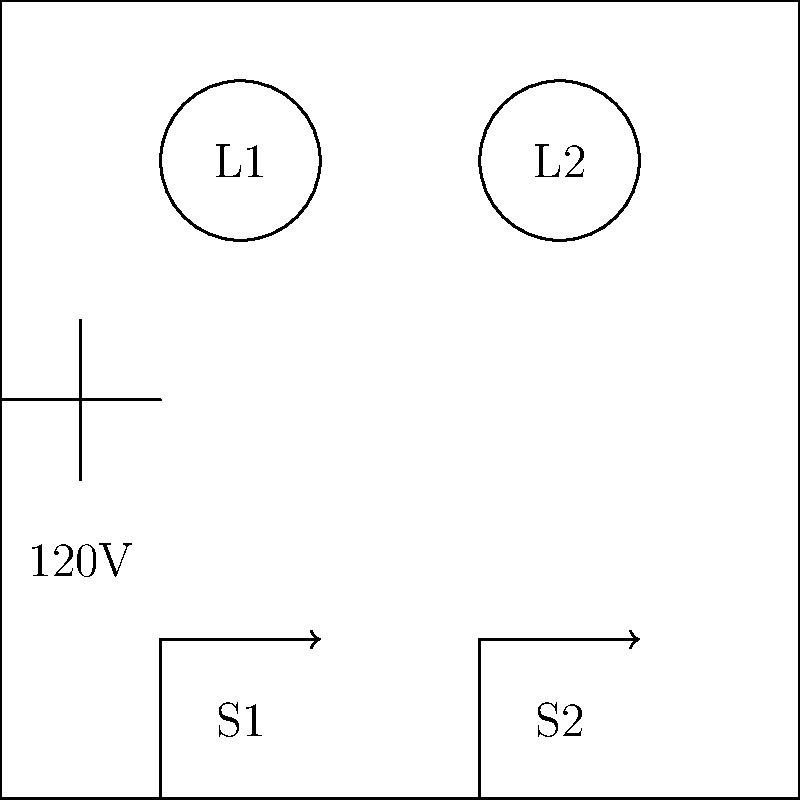In the residential electrical wiring schematic shown above, which represents a simple lighting circuit in a typical Oxfordshire home, what will happen when switch S1 is closed and switch S2 is open? To answer this question, let's analyze the circuit step-by-step:

1. The circuit shows a 120V power source, which is typical for residential lighting circuits.

2. There are two switches (S1 and S2) and two light bulbs (L1 and L2) in the circuit.

3. The switches and light bulbs are connected in parallel to the power source.

4. When a switch is closed, it completes the circuit for its corresponding light bulb.

5. In this scenario:
   - S1 is closed, which means it completes the circuit for L1.
   - S2 is open, which means it breaks the circuit for L2.

6. When a circuit is complete, current can flow, and the connected device (in this case, a light bulb) will operate.

7. When a circuit is broken, no current flows, and the connected device will not operate.

Therefore, when S1 is closed and S2 is open, L1 will receive power and light up, while L2 will remain off due to the open switch.
Answer: L1 will light up, L2 will remain off. 